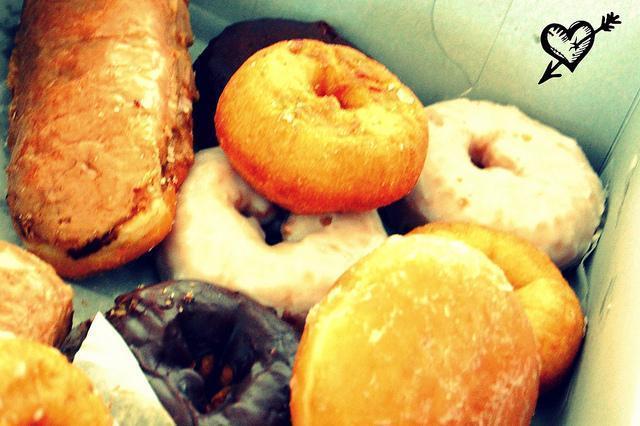How many donuts have vanilla frosting?
Give a very brief answer. 2. How many donuts are there?
Give a very brief answer. 8. 